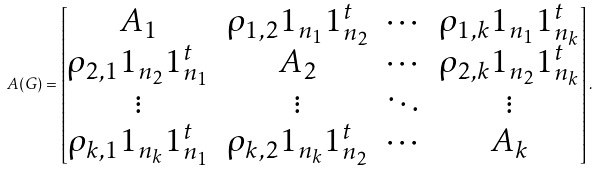Convert formula to latex. <formula><loc_0><loc_0><loc_500><loc_500>A ( G ) = \begin{bmatrix} A _ { 1 } & \rho _ { 1 , 2 } 1 _ { n _ { 1 } } 1 _ { n _ { 2 } } ^ { t } & \cdots & \rho _ { 1 , k } 1 _ { n _ { 1 } } 1 _ { n _ { k } } ^ { t } \\ \rho _ { 2 , 1 } 1 _ { n _ { 2 } } 1 _ { n _ { 1 } } ^ { t } & A _ { 2 } & \cdots & \rho _ { 2 , k } 1 _ { n _ { 2 } } 1 _ { n _ { k } } ^ { t } \\ \vdots & \vdots & \ddots & \vdots \\ \rho _ { k , 1 } 1 _ { n _ { k } } 1 _ { n _ { 1 } } ^ { t } & \rho _ { k , 2 } 1 _ { n _ { k } } 1 _ { n _ { 2 } } ^ { t } & \cdots & A _ { k } \end{bmatrix} .</formula> 